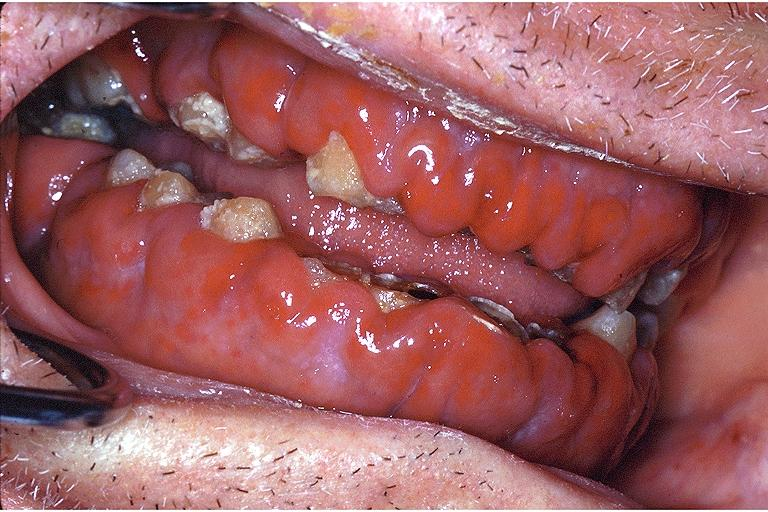what does this image show?
Answer the question using a single word or phrase. Gingival leukemic infiltrate 